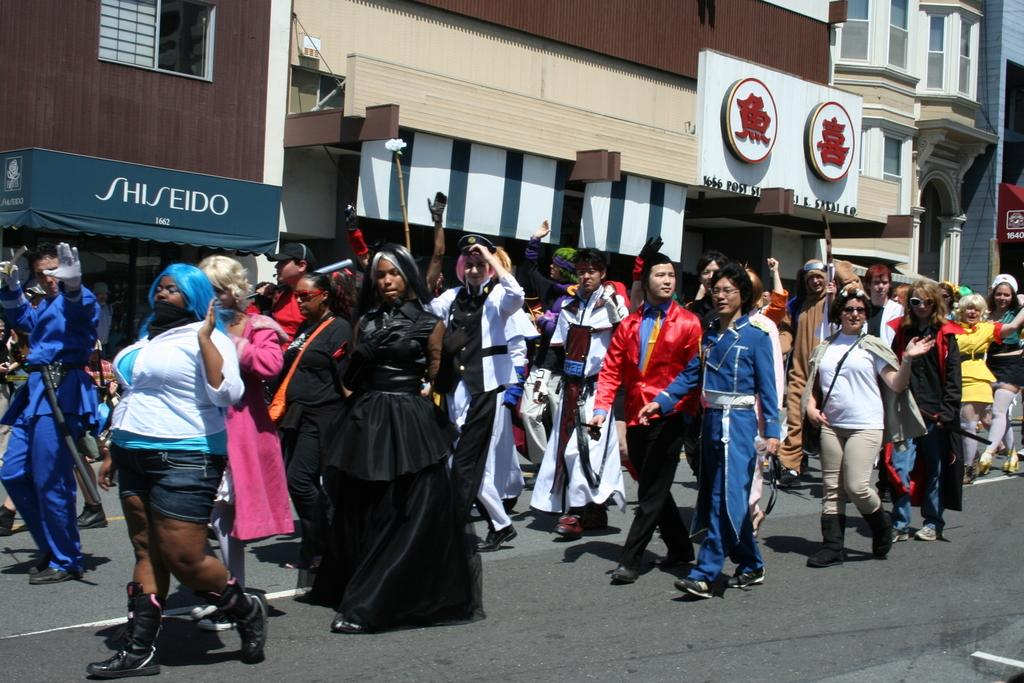What are the people in the image doing? The people in the image are walking on the road. What can be seen in the background of the image? There are buildings visible in the image. What type of signage is present in the image? Name boards are present in the image. Can you see any bananas hanging from the buildings in the image? There are no bananas visible in the image; it features people walking on the road and buildings in the background. Is there a turkey walking alongside the people in the image? There is no turkey present in the image; it only shows people walking on the road. 